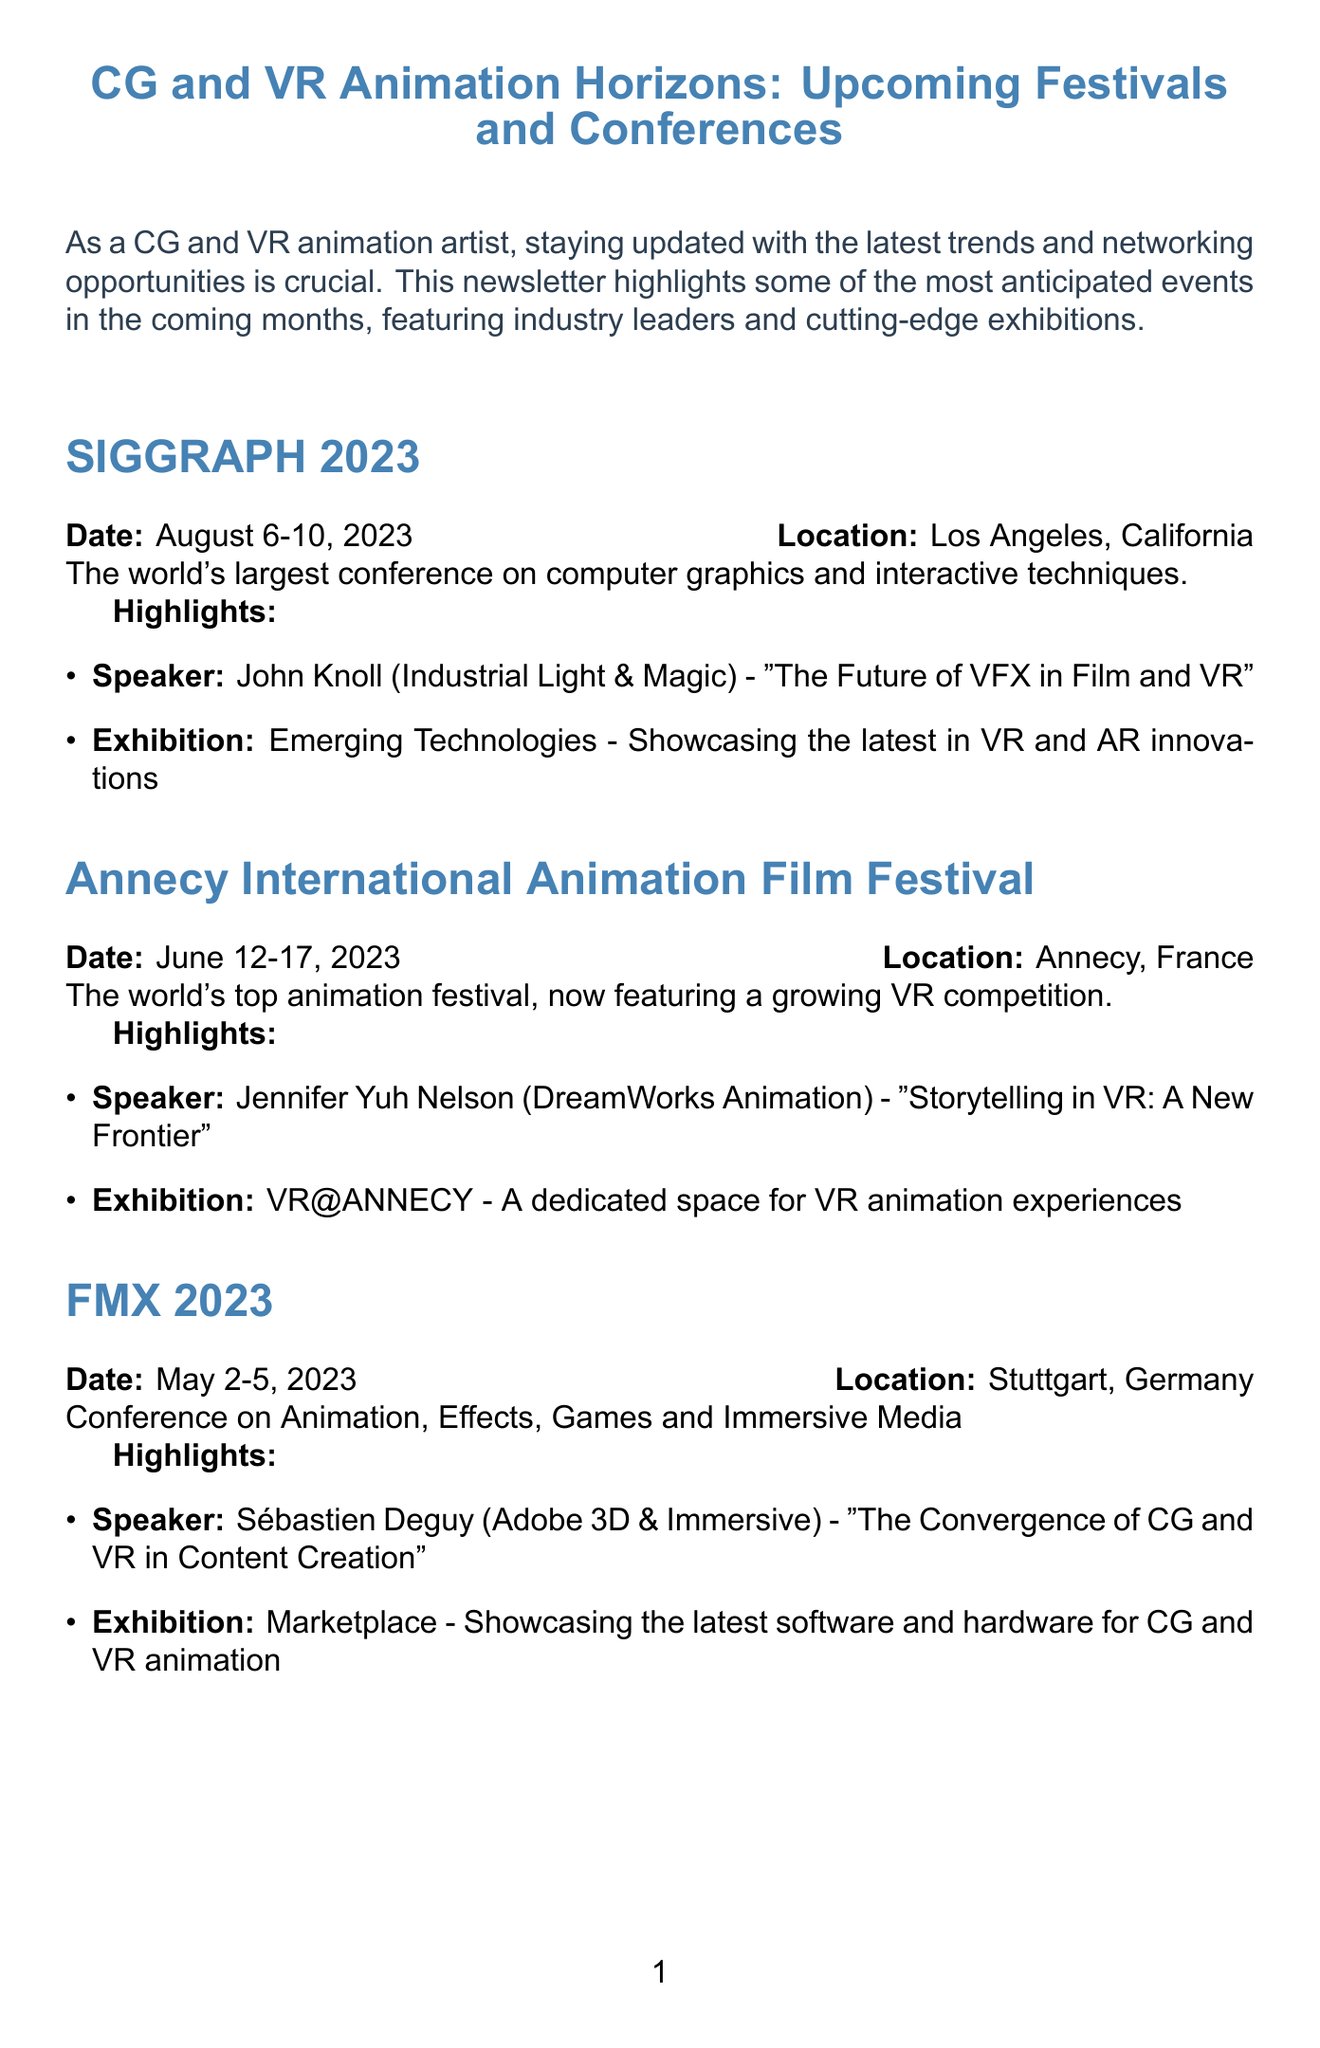What is the date of SIGGRAPH 2023? The date for SIGGRAPH 2023 is provided in the document as August 6-10, 2023.
Answer: August 6-10, 2023 Who is the speaker at the Annecy International Animation Film Festival? The document lists Jennifer Yuh Nelson from DreamWorks Animation as a speaker at the event.
Answer: Jennifer Yuh Nelson What is the location of FMX 2023? The location of FMX 2023 is mentioned in the document as Stuttgart, Germany.
Answer: Stuttgart, Germany What is highlighted at Laval Virtual? The document highlights a competition for innovative VR and AR projects called ReVolution at Laval Virtual.
Answer: ReVolution Which company is Sébastien Deguy affiliated with? The document specifies that Sébastien Deguy is affiliated with Adobe 3D & Immersive.
Answer: Adobe 3D & Immersive What type of event is the Annecy International Animation Film Festival? The document describes it as the world's top animation festival with a growing VR competition.
Answer: Animation festival What is the main focus of SIGGRAPH 2023? The main focus is on computer graphics and interactive techniques as stated in the document.
Answer: Computer graphics and interactive techniques What is the conclusion of the newsletter about? The conclusion emphasizes learning opportunities and staying updated in CG and VR animation.
Answer: Learning opportunities and staying updated 